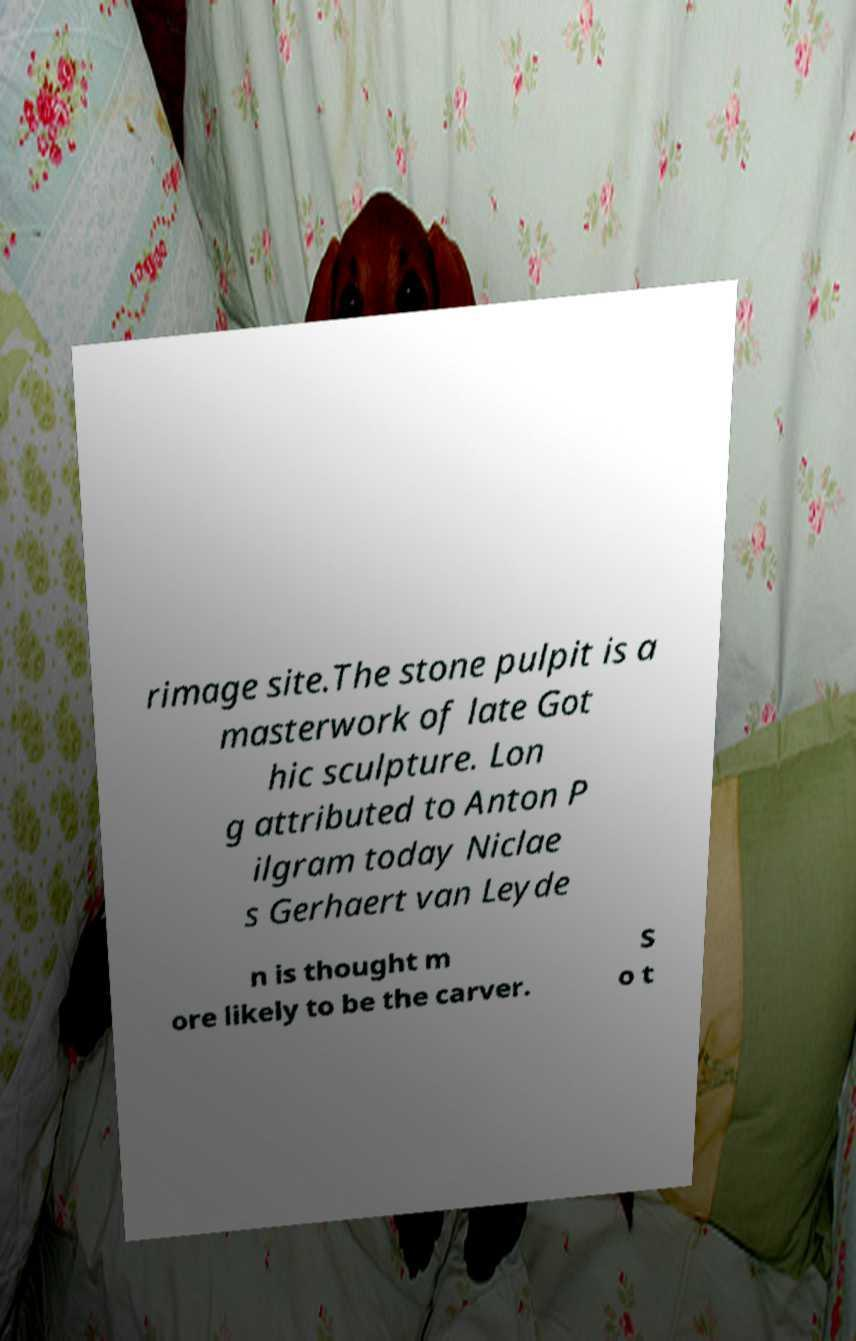Please read and relay the text visible in this image. What does it say? rimage site.The stone pulpit is a masterwork of late Got hic sculpture. Lon g attributed to Anton P ilgram today Niclae s Gerhaert van Leyde n is thought m ore likely to be the carver. S o t 